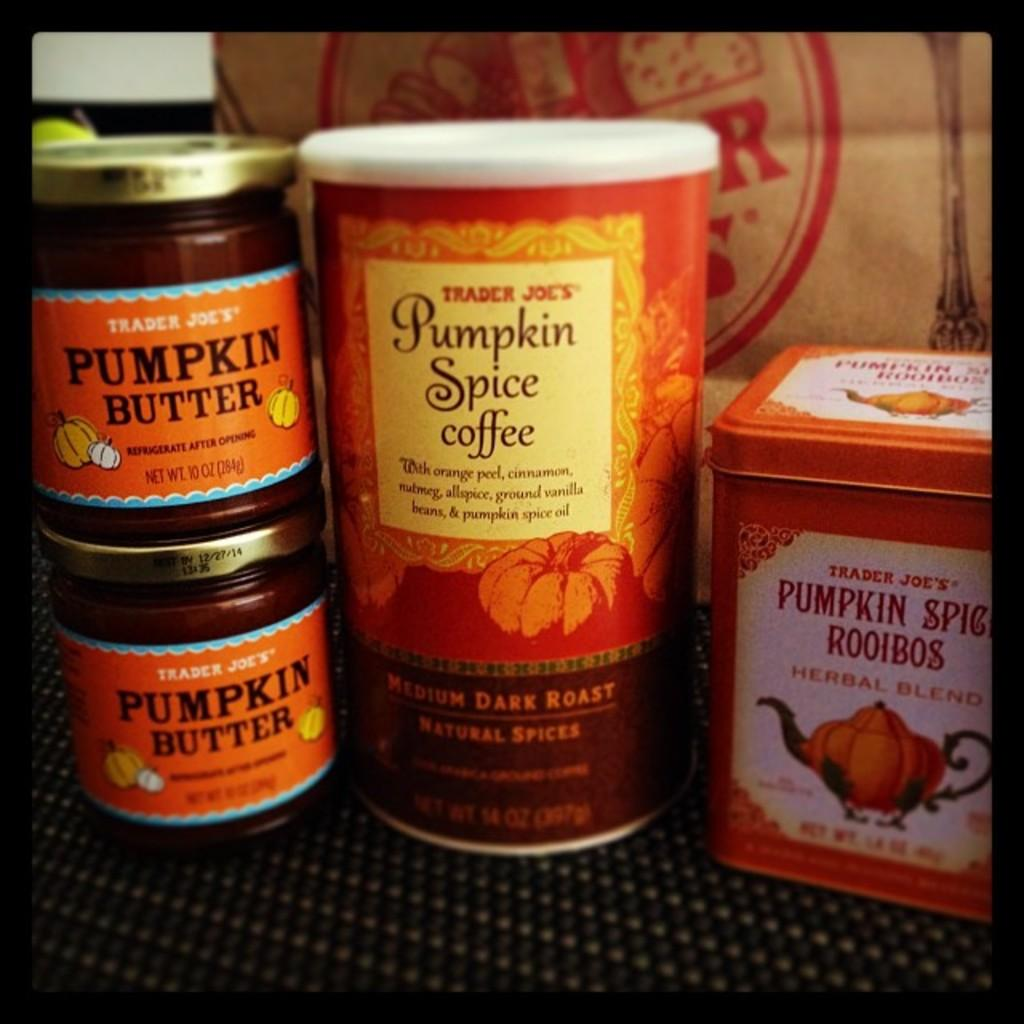<image>
Give a short and clear explanation of the subsequent image. A bunch of pumpkin themed things like pumpkin spice coffee all from Trader Joe's. 